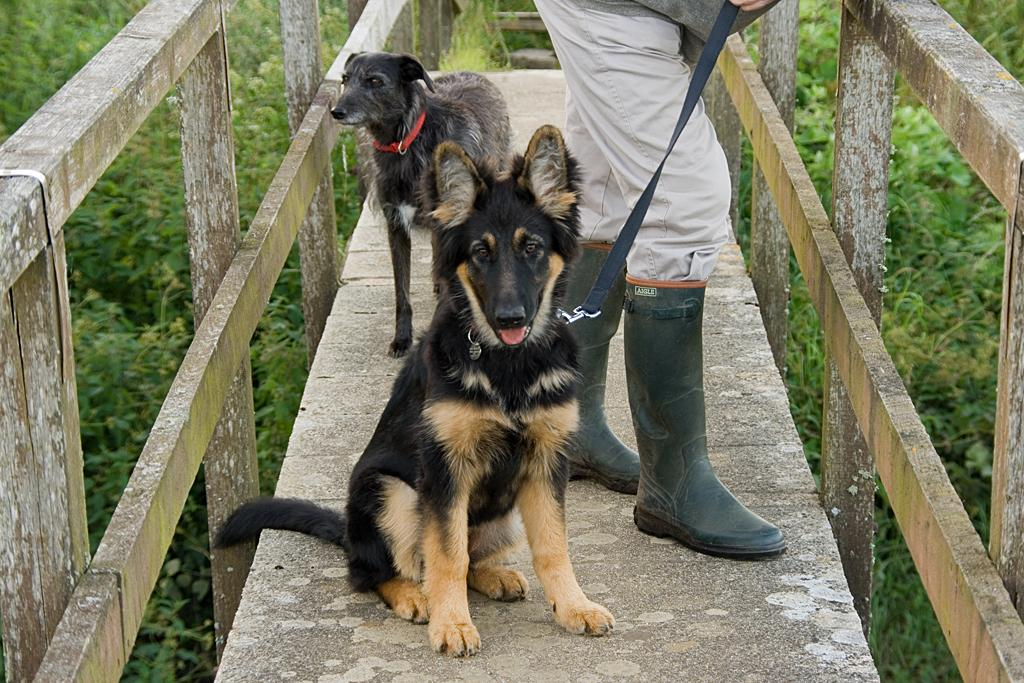What animals are in the center of the image? There are dogs in the center of the image. What else can be seen in the center of the image? There is a person on the walkway in the center of the image. What type of vegetation is on the right side of the image? There are plants on the right side of the image. What type of vegetation is on the left side of the image? There are plants on the left side of the image. What substance is falling from the sky during the rainstorm in the image? There is no rainstorm present in the image, so it is not possible to determine what substance might be falling from the sky. 